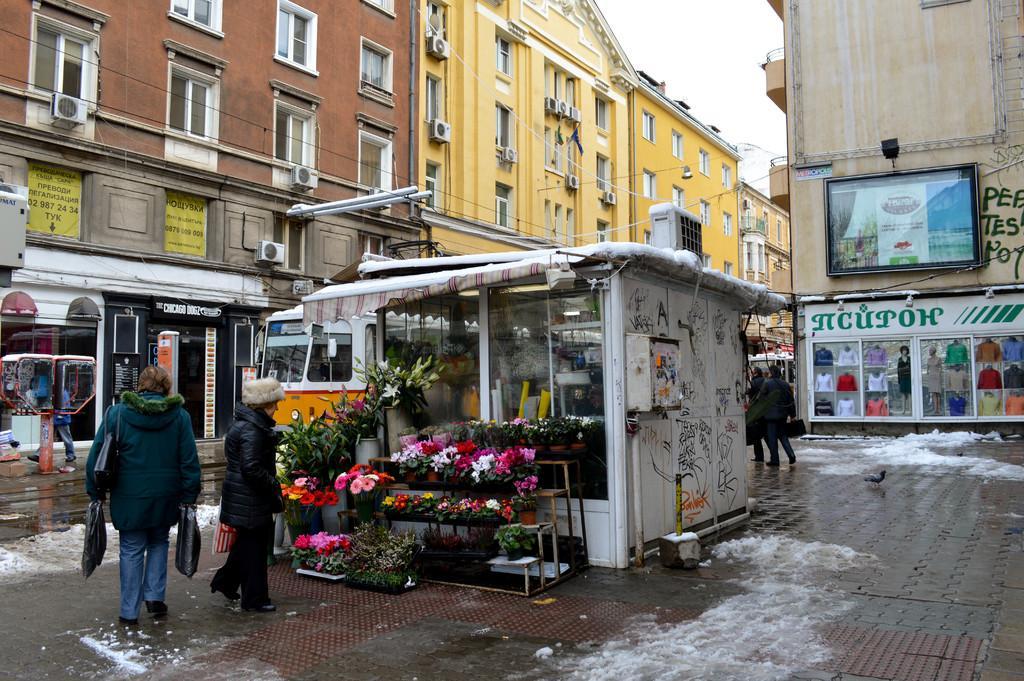Describe this image in one or two sentences. In the picture we can see a path on it, we can see a flower bookey shop with bookies are placed out of the shop on stands and besides, we can see a person standing and looking at the bookies and one person is walking holding a bag and in the background, we can see some buildings which are yellow and brown in color with windows, and glasses to it and besides we can see another building with a screen and we can also see a sky. 